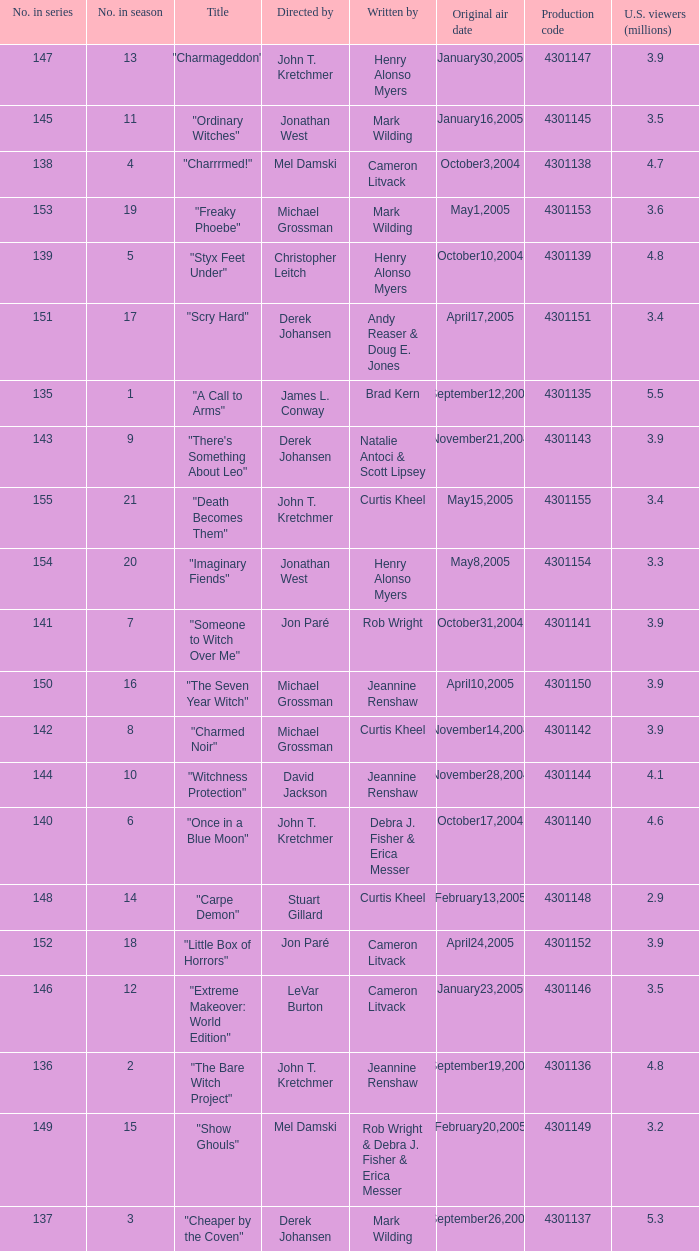What is the no in series when rob wright & debra j. fisher & erica messer were the writers? 149.0. 